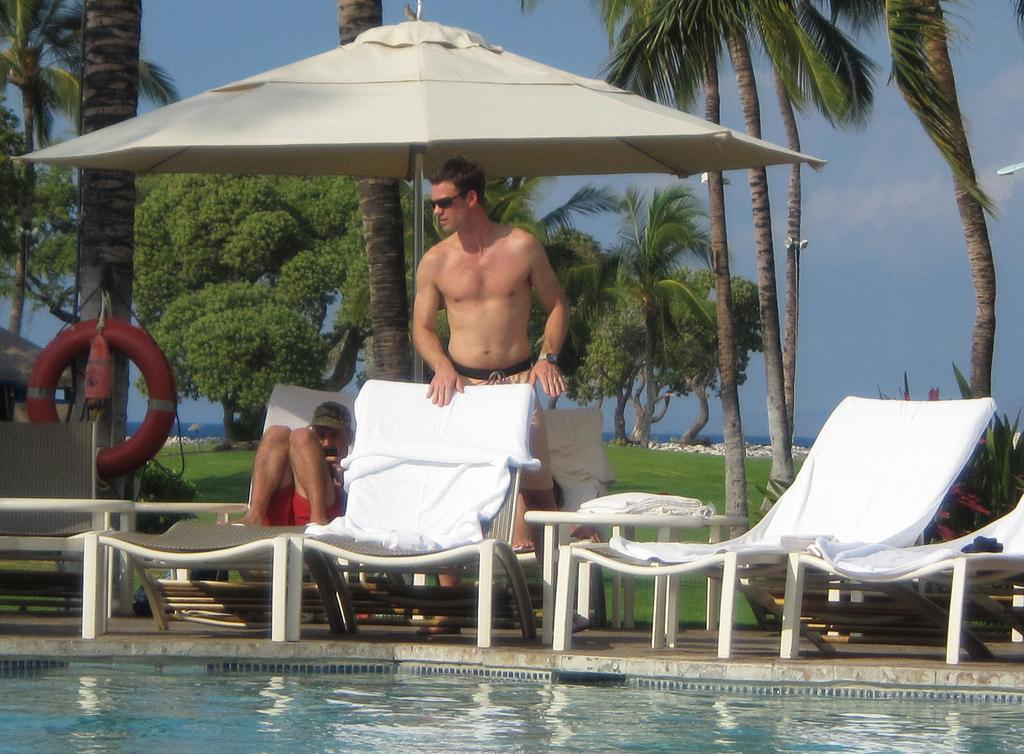What is the position of the person in the image? There is a person standing in front of a chair. Can you describe the position of the other person in the image? There is another person sitting behind the standing person. What type of vegetation can be seen in the background of the image? There are trees visible at the back of the scene. What body of water is present in the image? There is water in a pool in the front of the scene. What shape is the dirt in the image? There is no dirt present in the image, so it is not possible to determine its shape. 